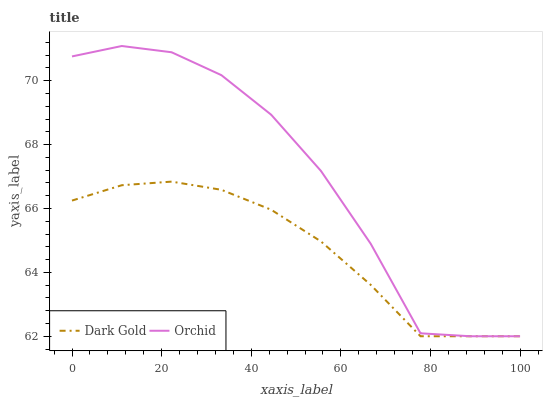Does Dark Gold have the maximum area under the curve?
Answer yes or no. No. Is Dark Gold the roughest?
Answer yes or no. No. Does Dark Gold have the highest value?
Answer yes or no. No. 